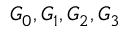<formula> <loc_0><loc_0><loc_500><loc_500>G _ { 0 } , G _ { 1 } , G _ { 2 } , G _ { 3 }</formula> 